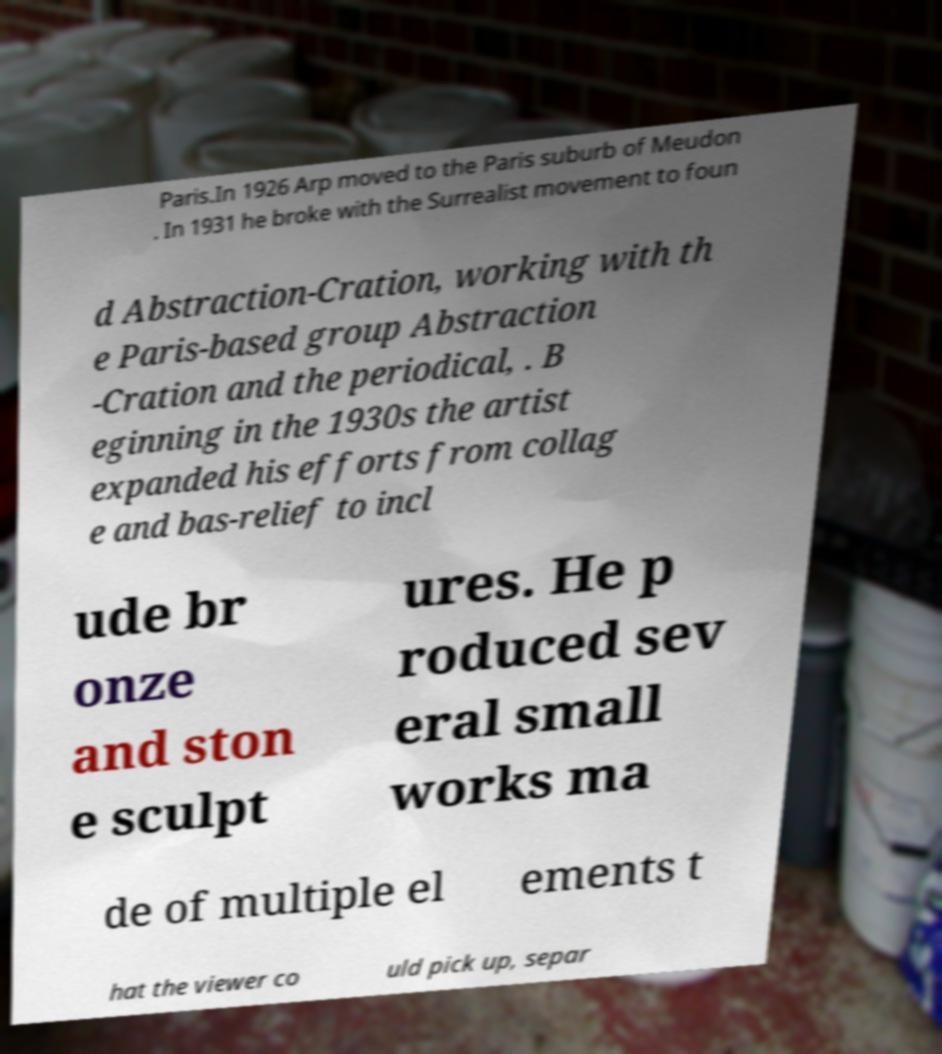For documentation purposes, I need the text within this image transcribed. Could you provide that? Paris.In 1926 Arp moved to the Paris suburb of Meudon . In 1931 he broke with the Surrealist movement to foun d Abstraction-Cration, working with th e Paris-based group Abstraction -Cration and the periodical, . B eginning in the 1930s the artist expanded his efforts from collag e and bas-relief to incl ude br onze and ston e sculpt ures. He p roduced sev eral small works ma de of multiple el ements t hat the viewer co uld pick up, separ 